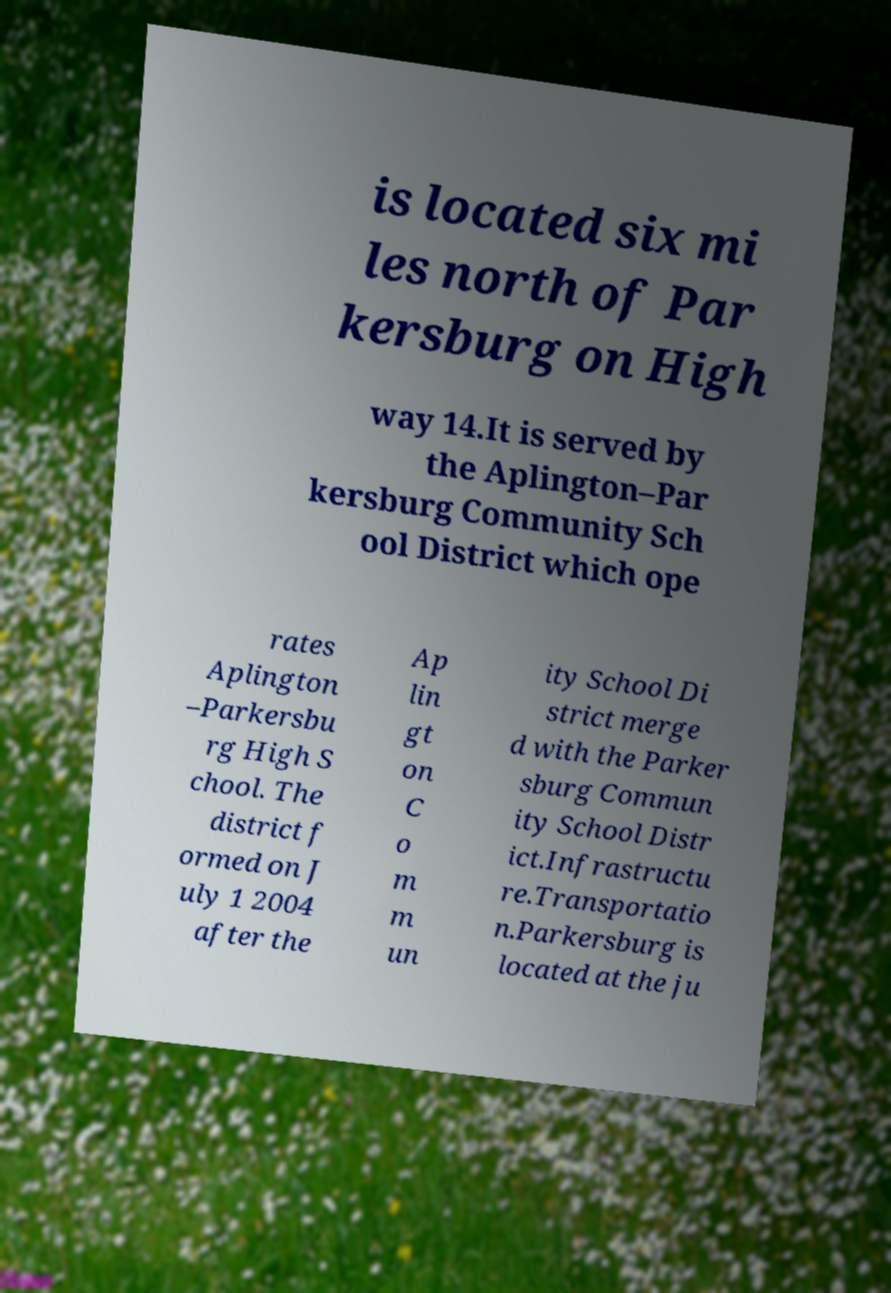I need the written content from this picture converted into text. Can you do that? is located six mi les north of Par kersburg on High way 14.It is served by the Aplington–Par kersburg Community Sch ool District which ope rates Aplington –Parkersbu rg High S chool. The district f ormed on J uly 1 2004 after the Ap lin gt on C o m m un ity School Di strict merge d with the Parker sburg Commun ity School Distr ict.Infrastructu re.Transportatio n.Parkersburg is located at the ju 